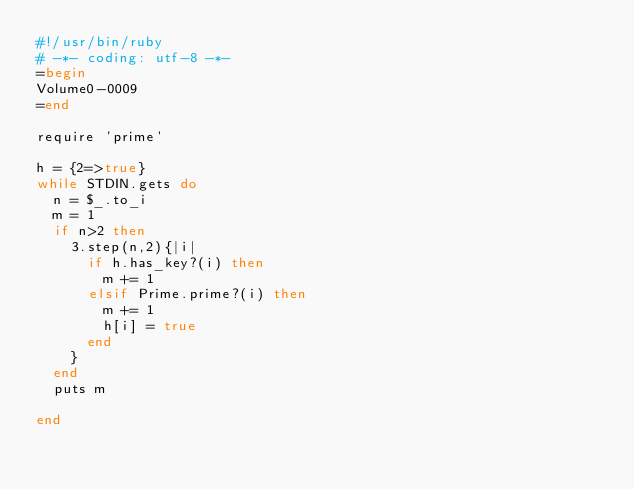<code> <loc_0><loc_0><loc_500><loc_500><_Ruby_>#!/usr/bin/ruby
# -*- coding: utf-8 -*-
=begin
Volume0-0009
=end

require 'prime'

h = {2=>true}
while STDIN.gets do
  n = $_.to_i
  m = 1
  if n>2 then
    3.step(n,2){|i|
      if h.has_key?(i) then
        m += 1
      elsif Prime.prime?(i) then
        m += 1
        h[i] = true
      end
    }
  end
  puts m

end</code> 